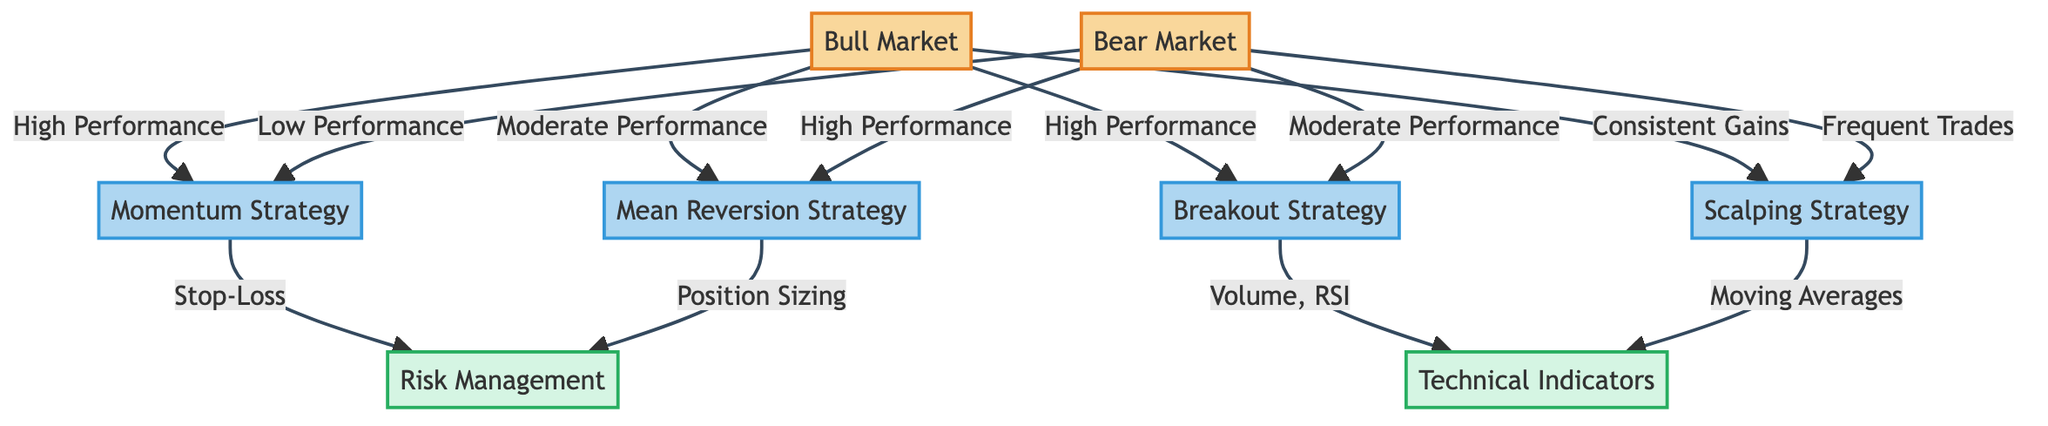What is the performance of the Momentum Strategy in a Bull Market? The diagram indicates that the Momentum Strategy shows "High Performance" in a Bull Market. This can be directly observed from the flow connecting the Bull Market node to the Momentum Strategy node.
Answer: High Performance What is the relationship between the Breakout Strategy and Technical Indicators? The diagram shows that the Breakout Strategy leads to the Technical Indicators node with the label "Volume, RSI." This indicates that the Breakout Strategy relies on these technical indicators for its execution.
Answer: Volume, RSI How many trading strategies are mentioned in the diagram? By counting the strategy nodes connected to both market types, we find four strategies: Momentum Strategy, Mean Reversion Strategy, Breakout Strategy, and Scalping Strategy. Thus, the total count of trading strategies is four.
Answer: 4 What is the performance of the Mean Reversion Strategy in a Bear Market? According to the diagram, the Mean Reversion Strategy shows "High Performance" in a Bear Market, as indicated by the linking edge between the Bear Market node and the Mean Reversion Strategy node.
Answer: High Performance Which strategy is associated with Stop-Loss as part of Risk Management? The diagram connects the Momentum Strategy to the Risk Management node with the label "Stop-Loss." This indicates that the Momentum Strategy incorporates Stop-Loss as a component of its risk management.
Answer: Stop-Loss Which strategy utilizes Moving Averages as a Technical Indicator? The diagram connects the Scalping Strategy to the Technical Indicators node with the label "Moving Averages." This means that the Scalping Strategy employs Moving Averages in its trading decisions.
Answer: Moving Averages What type of market shows frequent trades for the Scalping Strategy? The diagram specifies that in the Bear Market scenario, the Scalping Strategy is linked by the label "Frequent Trades," indicating that this strategy is characterized by the frequency of trading during bear market conditions.
Answer: Bear Market What performance does the Breakout Strategy show in a Bull Market? The diagram illustrates that the Breakout Strategy is associated with "High Performance" within a Bull Market, demonstrated by the direct flow from the Bull Market node to the Breakout Strategy node.
Answer: High Performance What risk management technique is linked to the Mean Reversion Strategy? The diagram connects the Mean Reversion Strategy to the Risk Management node with the label "Position Sizing," indicating that this strategy employs position sizing as a risk management technique.
Answer: Position Sizing 